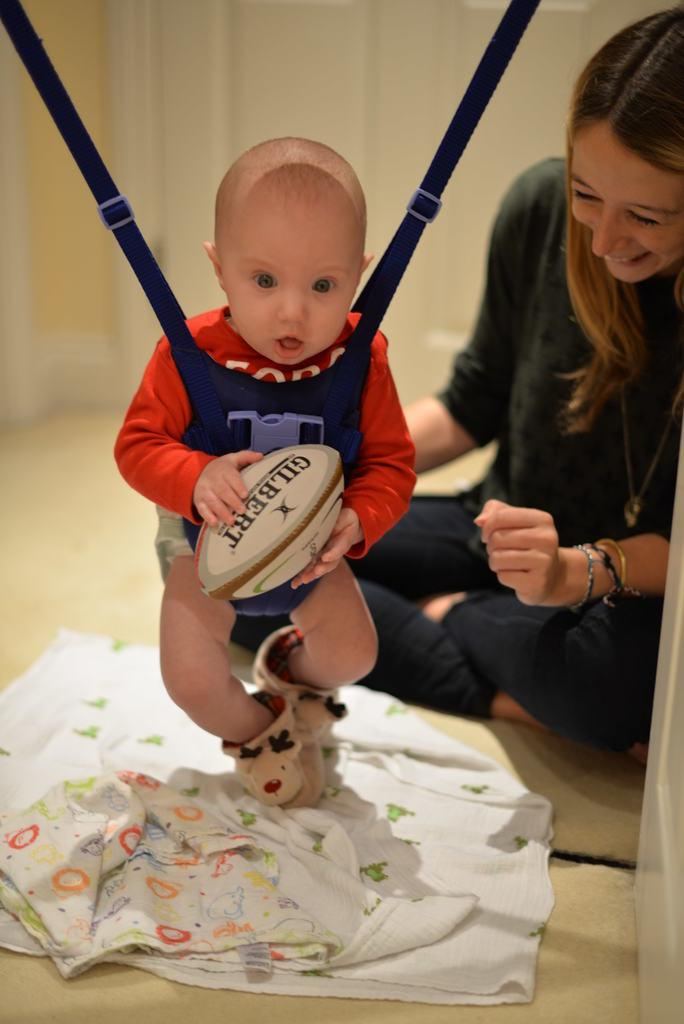What is the main subject of the image? The main subjects of the image are a boy and a girl. What is the boy doing in the image? The boy is holding an object and standing on the floor. What is the girl doing in the image? The girl is sitting on the floor and smiling. What can be seen in the background of the image? There is a wall in the background of the image. What type of stamp can be seen on the calendar in the image? There is no stamp or calendar present in the image. 